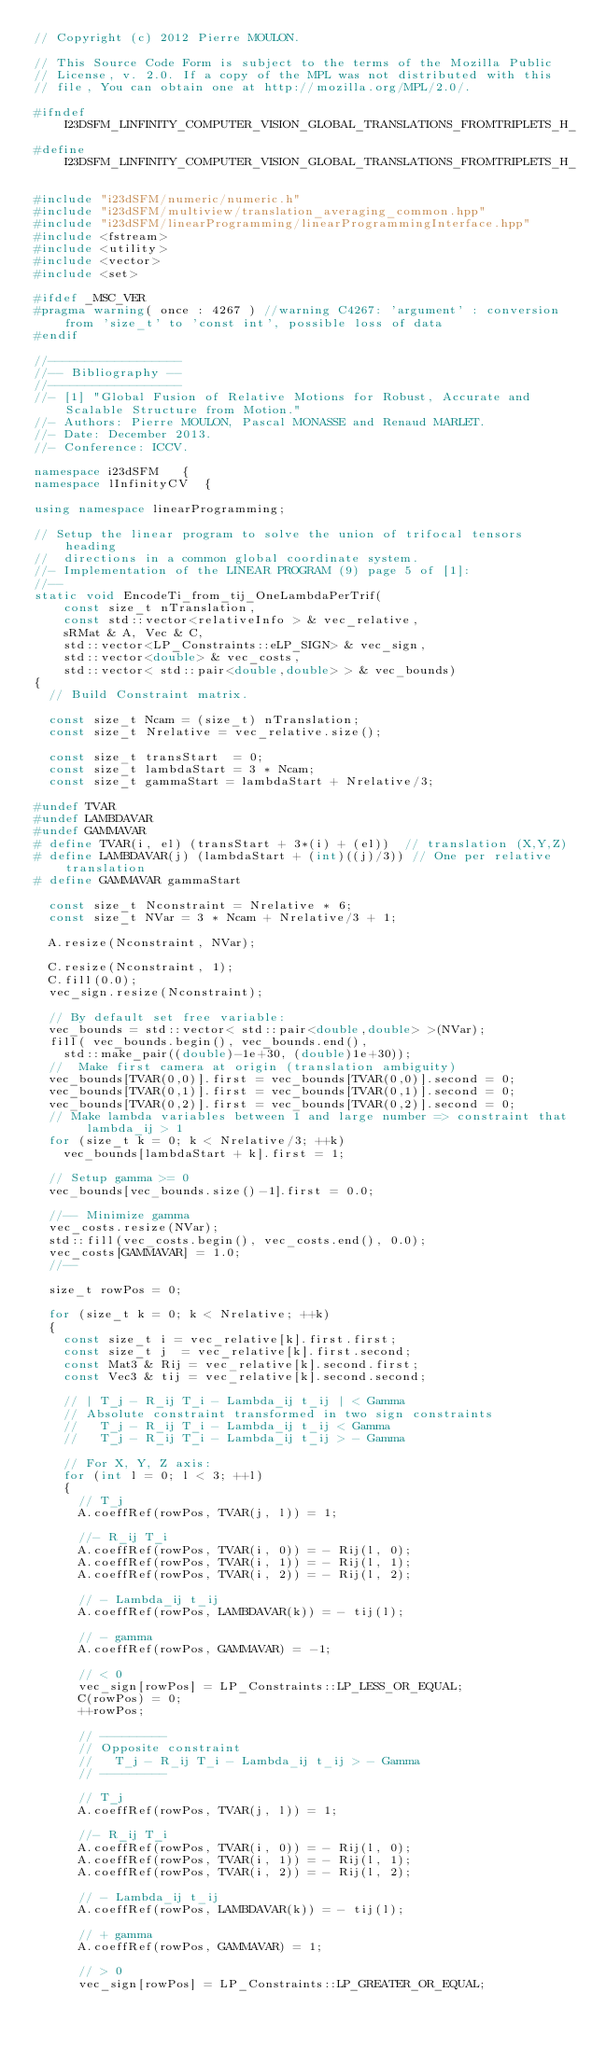<code> <loc_0><loc_0><loc_500><loc_500><_C++_>// Copyright (c) 2012 Pierre MOULON.

// This Source Code Form is subject to the terms of the Mozilla Public
// License, v. 2.0. If a copy of the MPL was not distributed with this
// file, You can obtain one at http://mozilla.org/MPL/2.0/.

#ifndef I23DSFM_LINFINITY_COMPUTER_VISION_GLOBAL_TRANSLATIONS_FROMTRIPLETS_H_
#define I23DSFM_LINFINITY_COMPUTER_VISION_GLOBAL_TRANSLATIONS_FROMTRIPLETS_H_

#include "i23dSFM/numeric/numeric.h"
#include "i23dSFM/multiview/translation_averaging_common.hpp"
#include "i23dSFM/linearProgramming/linearProgrammingInterface.hpp"
#include <fstream>
#include <utility>
#include <vector>
#include <set>

#ifdef _MSC_VER
#pragma warning( once : 4267 ) //warning C4267: 'argument' : conversion from 'size_t' to 'const int', possible loss of data
#endif

//------------------
//-- Bibliography --
//------------------
//- [1] "Global Fusion of Relative Motions for Robust, Accurate and Scalable Structure from Motion."
//- Authors: Pierre MOULON, Pascal MONASSE and Renaud MARLET.
//- Date: December 2013.
//- Conference: ICCV.

namespace i23dSFM   {
namespace lInfinityCV  {

using namespace linearProgramming;

// Setup the linear program to solve the union of trifocal tensors heading
//  directions in a common global coordinate system.
//- Implementation of the LINEAR PROGRAM (9) page 5 of [1]:
//--
static void EncodeTi_from_tij_OneLambdaPerTrif(
    const size_t nTranslation,
    const std::vector<relativeInfo > & vec_relative,
    sRMat & A, Vec & C,
    std::vector<LP_Constraints::eLP_SIGN> & vec_sign,
    std::vector<double> & vec_costs,
    std::vector< std::pair<double,double> > & vec_bounds)
{
  // Build Constraint matrix.

  const size_t Ncam = (size_t) nTranslation;
  const size_t Nrelative = vec_relative.size();

  const size_t transStart  = 0;
  const size_t lambdaStart = 3 * Ncam;
  const size_t gammaStart = lambdaStart + Nrelative/3;

#undef TVAR
#undef LAMBDAVAR
#undef GAMMAVAR
# define TVAR(i, el) (transStart + 3*(i) + (el))  // translation (X,Y,Z)
# define LAMBDAVAR(j) (lambdaStart + (int)((j)/3)) // One per relative translation
# define GAMMAVAR gammaStart

  const size_t Nconstraint = Nrelative * 6;
  const size_t NVar = 3 * Ncam + Nrelative/3 + 1;

  A.resize(Nconstraint, NVar);

  C.resize(Nconstraint, 1);
  C.fill(0.0);
  vec_sign.resize(Nconstraint);

  // By default set free variable:
  vec_bounds = std::vector< std::pair<double,double> >(NVar);
  fill( vec_bounds.begin(), vec_bounds.end(),
    std::make_pair((double)-1e+30, (double)1e+30));
  //  Make first camera at origin (translation ambiguity)
  vec_bounds[TVAR(0,0)].first = vec_bounds[TVAR(0,0)].second = 0;
  vec_bounds[TVAR(0,1)].first = vec_bounds[TVAR(0,1)].second = 0;
  vec_bounds[TVAR(0,2)].first = vec_bounds[TVAR(0,2)].second = 0;
  // Make lambda variables between 1 and large number => constraint that lambda_ij > 1
  for (size_t k = 0; k < Nrelative/3; ++k)
    vec_bounds[lambdaStart + k].first = 1;

  // Setup gamma >= 0
  vec_bounds[vec_bounds.size()-1].first = 0.0;

  //-- Minimize gamma
  vec_costs.resize(NVar);
  std::fill(vec_costs.begin(), vec_costs.end(), 0.0);
  vec_costs[GAMMAVAR] = 1.0;
  //--

  size_t rowPos = 0;

  for (size_t k = 0; k < Nrelative; ++k)
  {
    const size_t i = vec_relative[k].first.first;
    const size_t j  = vec_relative[k].first.second;
    const Mat3 & Rij = vec_relative[k].second.first;
    const Vec3 & tij = vec_relative[k].second.second;

    // | T_j - R_ij T_i - Lambda_ij t_ij | < Gamma
    // Absolute constraint transformed in two sign constraints
    //   T_j - R_ij T_i - Lambda_ij t_ij < Gamma
    //   T_j - R_ij T_i - Lambda_ij t_ij > - Gamma

    // For X, Y, Z axis:
    for (int l = 0; l < 3; ++l)
    {
      // T_j
      A.coeffRef(rowPos, TVAR(j, l)) = 1;

      //- R_ij T_i
      A.coeffRef(rowPos, TVAR(i, 0)) = - Rij(l, 0);
      A.coeffRef(rowPos, TVAR(i, 1)) = - Rij(l, 1);
      A.coeffRef(rowPos, TVAR(i, 2)) = - Rij(l, 2);

      // - Lambda_ij t_ij
      A.coeffRef(rowPos, LAMBDAVAR(k)) = - tij(l);

      // - gamma
      A.coeffRef(rowPos, GAMMAVAR) = -1;

      // < 0
      vec_sign[rowPos] = LP_Constraints::LP_LESS_OR_EQUAL;
      C(rowPos) = 0;
      ++rowPos;

      // ---------
      // Opposite constraint
      //   T_j - R_ij T_i - Lambda_ij t_ij > - Gamma
      // ---------

      // T_j
      A.coeffRef(rowPos, TVAR(j, l)) = 1;

      //- R_ij T_i
      A.coeffRef(rowPos, TVAR(i, 0)) = - Rij(l, 0);
      A.coeffRef(rowPos, TVAR(i, 1)) = - Rij(l, 1);
      A.coeffRef(rowPos, TVAR(i, 2)) = - Rij(l, 2);

      // - Lambda_ij t_ij
      A.coeffRef(rowPos, LAMBDAVAR(k)) = - tij(l);

      // + gamma
      A.coeffRef(rowPos, GAMMAVAR) = 1;

      // > 0
      vec_sign[rowPos] = LP_Constraints::LP_GREATER_OR_EQUAL;</code> 